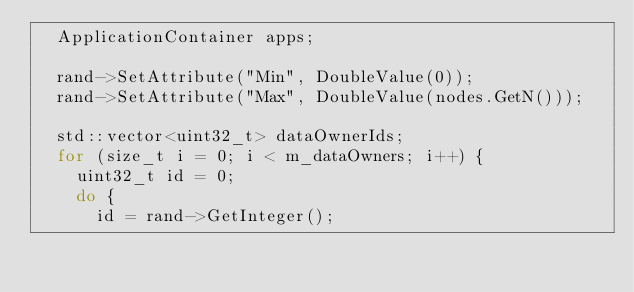Convert code to text. <code><loc_0><loc_0><loc_500><loc_500><_C++_>  ApplicationContainer apps;

  rand->SetAttribute("Min", DoubleValue(0));
  rand->SetAttribute("Max", DoubleValue(nodes.GetN()));

  std::vector<uint32_t> dataOwnerIds;
  for (size_t i = 0; i < m_dataOwners; i++) {
    uint32_t id = 0;
    do {
      id = rand->GetInteger();</code> 